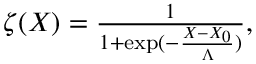<formula> <loc_0><loc_0><loc_500><loc_500>\begin{array} { r } { \zeta ( X ) = \frac { 1 } { 1 + \exp ( - \frac { X - X _ { 0 } } { \Lambda } ) } , } \end{array}</formula> 